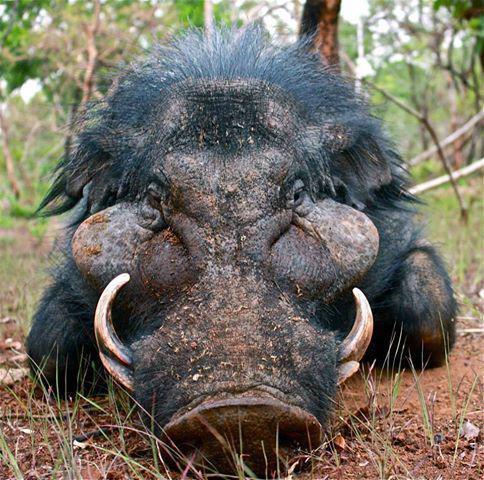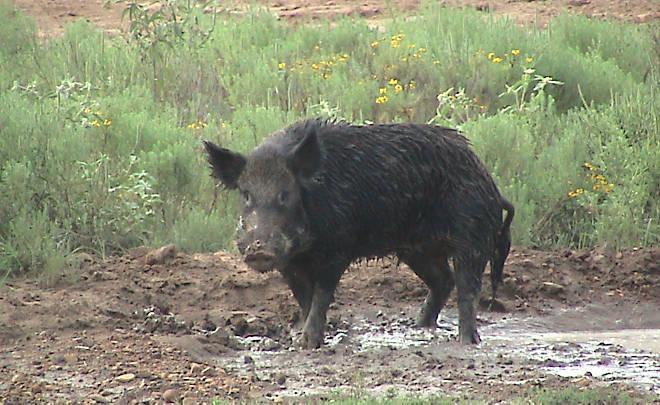The first image is the image on the left, the second image is the image on the right. Considering the images on both sides, is "One image shows a boar standing in the mud." valid? Answer yes or no. Yes. 